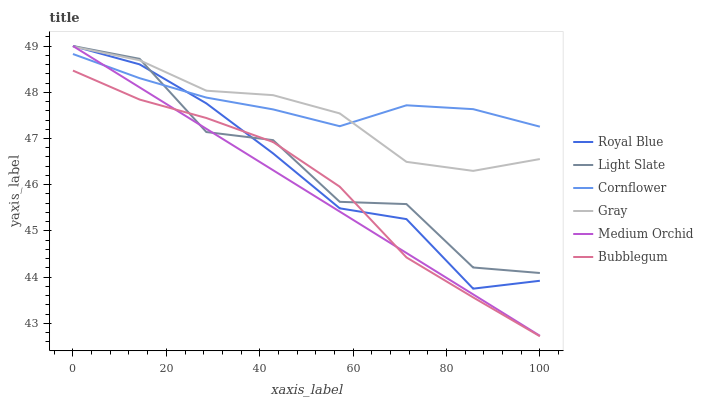Does Medium Orchid have the minimum area under the curve?
Answer yes or no. Yes. Does Cornflower have the maximum area under the curve?
Answer yes or no. Yes. Does Light Slate have the minimum area under the curve?
Answer yes or no. No. Does Light Slate have the maximum area under the curve?
Answer yes or no. No. Is Medium Orchid the smoothest?
Answer yes or no. Yes. Is Light Slate the roughest?
Answer yes or no. Yes. Is Cornflower the smoothest?
Answer yes or no. No. Is Cornflower the roughest?
Answer yes or no. No. Does Bubblegum have the lowest value?
Answer yes or no. Yes. Does Light Slate have the lowest value?
Answer yes or no. No. Does Royal Blue have the highest value?
Answer yes or no. Yes. Does Cornflower have the highest value?
Answer yes or no. No. Is Bubblegum less than Cornflower?
Answer yes or no. Yes. Is Gray greater than Bubblegum?
Answer yes or no. Yes. Does Royal Blue intersect Bubblegum?
Answer yes or no. Yes. Is Royal Blue less than Bubblegum?
Answer yes or no. No. Is Royal Blue greater than Bubblegum?
Answer yes or no. No. Does Bubblegum intersect Cornflower?
Answer yes or no. No. 